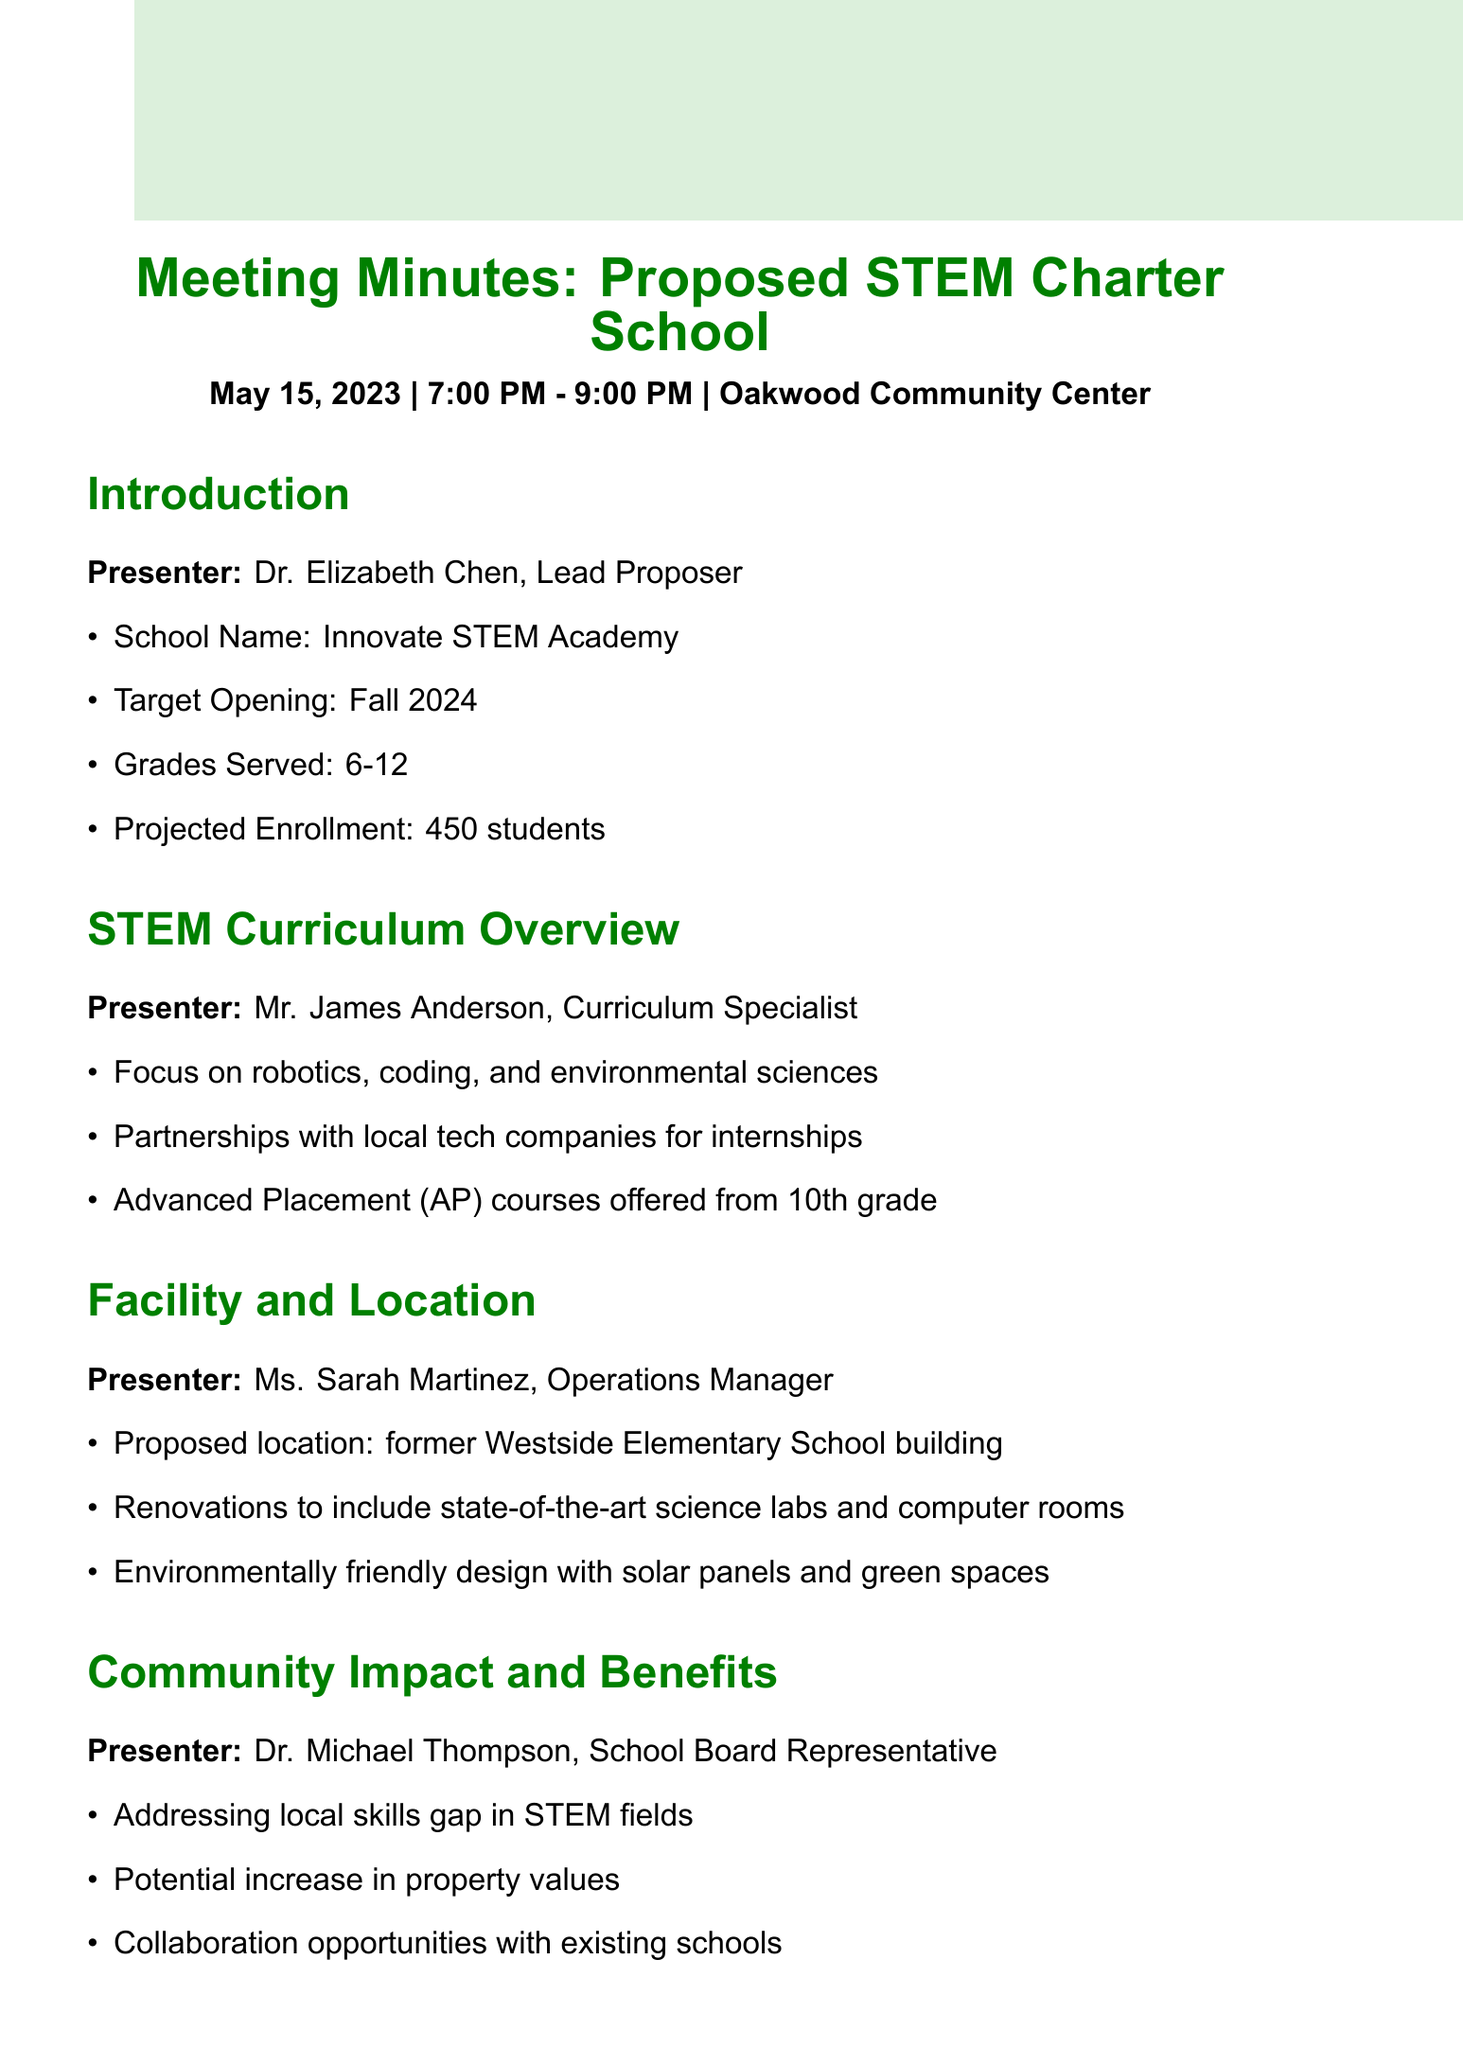What is the name of the proposed charter school? The document states that the proposed charter school is called Innovate STEM Academy.
Answer: Innovate STEM Academy What grades will the school serve? According to the document, the school will serve grades 6-12.
Answer: 6-12 Who is the presenter for the STEM curriculum overview? The presenter for the STEM curriculum overview listed in the document is Mr. James Anderson.
Answer: Mr. James Anderson When is the target opening for the school? The document indicates that the target opening for the school is Fall 2024.
Answer: Fall 2024 What is the projected student enrollment? The projected enrollment mentioned in the document for the school is 450 students.
Answer: 450 students What will be included in the proposed location's renovations? The document highlights that renovations will include state-of-the-art science labs and computer rooms.
Answer: Science labs and computer rooms How does the proposed school impact local skills? From the document, one benefit mentioned is addressing the local skills gap in STEM fields.
Answer: Skills gap in STEM fields What is an action item for the next steps regarding community interest? According to the document, one action item is to conduct a survey to gauge community interest and concerns.
Answer: Conduct survey How many attendees were present at the meeting? The document notes that there were 45 attendees present at the meeting.
Answer: 45 